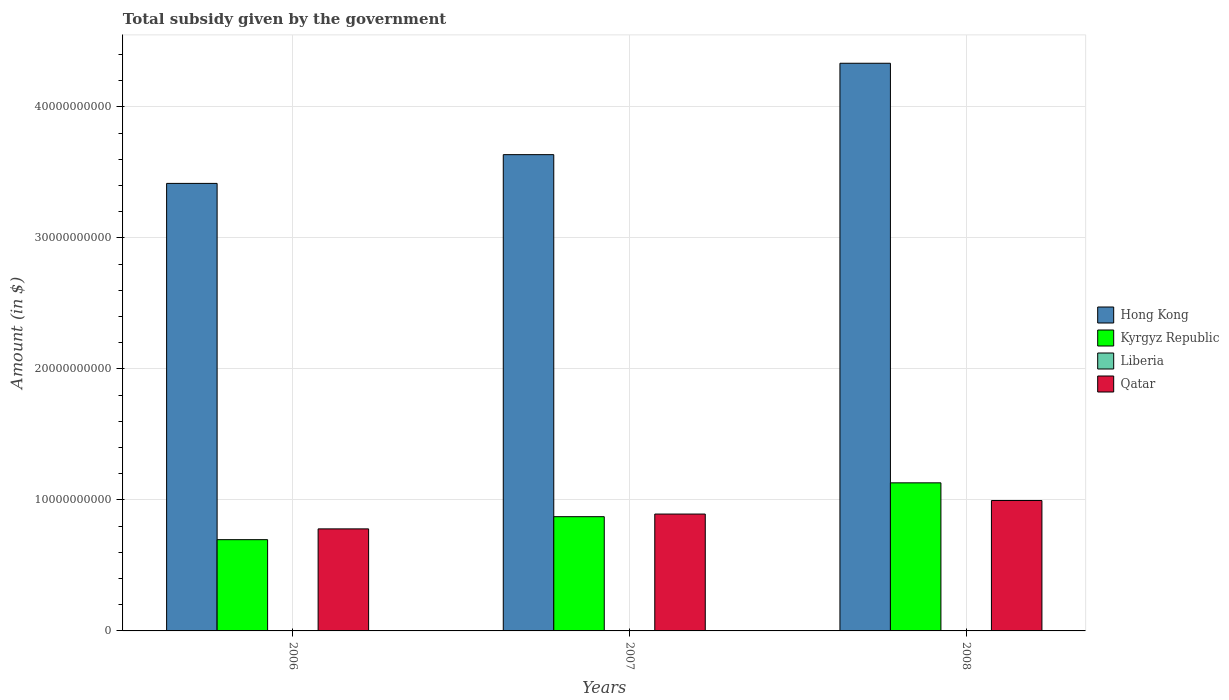How many different coloured bars are there?
Provide a short and direct response. 4. How many groups of bars are there?
Ensure brevity in your answer.  3. Are the number of bars per tick equal to the number of legend labels?
Your answer should be very brief. Yes. Are the number of bars on each tick of the X-axis equal?
Your answer should be compact. Yes. What is the label of the 2nd group of bars from the left?
Provide a succinct answer. 2007. In how many cases, is the number of bars for a given year not equal to the number of legend labels?
Your answer should be compact. 0. What is the total revenue collected by the government in Hong Kong in 2008?
Your answer should be compact. 4.33e+1. Across all years, what is the maximum total revenue collected by the government in Hong Kong?
Make the answer very short. 4.33e+1. Across all years, what is the minimum total revenue collected by the government in Hong Kong?
Your response must be concise. 3.42e+1. In which year was the total revenue collected by the government in Liberia minimum?
Your response must be concise. 2006. What is the total total revenue collected by the government in Hong Kong in the graph?
Make the answer very short. 1.14e+11. What is the difference between the total revenue collected by the government in Kyrgyz Republic in 2006 and that in 2007?
Your answer should be compact. -1.75e+09. What is the difference between the total revenue collected by the government in Kyrgyz Republic in 2007 and the total revenue collected by the government in Liberia in 2006?
Ensure brevity in your answer.  8.72e+09. What is the average total revenue collected by the government in Kyrgyz Republic per year?
Give a very brief answer. 9.00e+09. In the year 2007, what is the difference between the total revenue collected by the government in Qatar and total revenue collected by the government in Hong Kong?
Offer a terse response. -2.74e+1. What is the ratio of the total revenue collected by the government in Hong Kong in 2007 to that in 2008?
Give a very brief answer. 0.84. What is the difference between the highest and the second highest total revenue collected by the government in Hong Kong?
Keep it short and to the point. 6.98e+09. What is the difference between the highest and the lowest total revenue collected by the government in Kyrgyz Republic?
Offer a very short reply. 4.34e+09. Is the sum of the total revenue collected by the government in Kyrgyz Republic in 2006 and 2007 greater than the maximum total revenue collected by the government in Qatar across all years?
Offer a very short reply. Yes. Is it the case that in every year, the sum of the total revenue collected by the government in Kyrgyz Republic and total revenue collected by the government in Hong Kong is greater than the sum of total revenue collected by the government in Liberia and total revenue collected by the government in Qatar?
Provide a short and direct response. No. What does the 3rd bar from the left in 2007 represents?
Offer a very short reply. Liberia. What does the 4th bar from the right in 2008 represents?
Your answer should be very brief. Hong Kong. Is it the case that in every year, the sum of the total revenue collected by the government in Liberia and total revenue collected by the government in Qatar is greater than the total revenue collected by the government in Hong Kong?
Keep it short and to the point. No. Are all the bars in the graph horizontal?
Provide a short and direct response. No. Are the values on the major ticks of Y-axis written in scientific E-notation?
Give a very brief answer. No. Does the graph contain any zero values?
Your answer should be compact. No. Does the graph contain grids?
Give a very brief answer. Yes. How are the legend labels stacked?
Offer a terse response. Vertical. What is the title of the graph?
Provide a succinct answer. Total subsidy given by the government. Does "Chile" appear as one of the legend labels in the graph?
Your answer should be compact. No. What is the label or title of the Y-axis?
Provide a succinct answer. Amount (in $). What is the Amount (in $) of Hong Kong in 2006?
Offer a very short reply. 3.42e+1. What is the Amount (in $) of Kyrgyz Republic in 2006?
Ensure brevity in your answer.  6.97e+09. What is the Amount (in $) in Liberia in 2006?
Make the answer very short. 1.65e+05. What is the Amount (in $) in Qatar in 2006?
Keep it short and to the point. 7.79e+09. What is the Amount (in $) of Hong Kong in 2007?
Your answer should be compact. 3.64e+1. What is the Amount (in $) in Kyrgyz Republic in 2007?
Provide a succinct answer. 8.72e+09. What is the Amount (in $) of Liberia in 2007?
Keep it short and to the point. 2.89e+05. What is the Amount (in $) in Qatar in 2007?
Provide a short and direct response. 8.92e+09. What is the Amount (in $) in Hong Kong in 2008?
Your response must be concise. 4.33e+1. What is the Amount (in $) of Kyrgyz Republic in 2008?
Your answer should be very brief. 1.13e+1. What is the Amount (in $) of Liberia in 2008?
Your answer should be compact. 6.89e+05. What is the Amount (in $) of Qatar in 2008?
Offer a very short reply. 9.95e+09. Across all years, what is the maximum Amount (in $) of Hong Kong?
Offer a terse response. 4.33e+1. Across all years, what is the maximum Amount (in $) in Kyrgyz Republic?
Make the answer very short. 1.13e+1. Across all years, what is the maximum Amount (in $) of Liberia?
Provide a short and direct response. 6.89e+05. Across all years, what is the maximum Amount (in $) of Qatar?
Ensure brevity in your answer.  9.95e+09. Across all years, what is the minimum Amount (in $) of Hong Kong?
Offer a very short reply. 3.42e+1. Across all years, what is the minimum Amount (in $) of Kyrgyz Republic?
Offer a very short reply. 6.97e+09. Across all years, what is the minimum Amount (in $) of Liberia?
Ensure brevity in your answer.  1.65e+05. Across all years, what is the minimum Amount (in $) of Qatar?
Your response must be concise. 7.79e+09. What is the total Amount (in $) of Hong Kong in the graph?
Keep it short and to the point. 1.14e+11. What is the total Amount (in $) of Kyrgyz Republic in the graph?
Provide a short and direct response. 2.70e+1. What is the total Amount (in $) of Liberia in the graph?
Give a very brief answer. 1.14e+06. What is the total Amount (in $) in Qatar in the graph?
Your response must be concise. 2.67e+1. What is the difference between the Amount (in $) in Hong Kong in 2006 and that in 2007?
Offer a terse response. -2.20e+09. What is the difference between the Amount (in $) in Kyrgyz Republic in 2006 and that in 2007?
Provide a succinct answer. -1.75e+09. What is the difference between the Amount (in $) of Liberia in 2006 and that in 2007?
Provide a short and direct response. -1.24e+05. What is the difference between the Amount (in $) in Qatar in 2006 and that in 2007?
Your answer should be very brief. -1.13e+09. What is the difference between the Amount (in $) in Hong Kong in 2006 and that in 2008?
Ensure brevity in your answer.  -9.17e+09. What is the difference between the Amount (in $) of Kyrgyz Republic in 2006 and that in 2008?
Ensure brevity in your answer.  -4.34e+09. What is the difference between the Amount (in $) in Liberia in 2006 and that in 2008?
Your response must be concise. -5.24e+05. What is the difference between the Amount (in $) of Qatar in 2006 and that in 2008?
Your response must be concise. -2.16e+09. What is the difference between the Amount (in $) in Hong Kong in 2007 and that in 2008?
Provide a short and direct response. -6.98e+09. What is the difference between the Amount (in $) in Kyrgyz Republic in 2007 and that in 2008?
Give a very brief answer. -2.58e+09. What is the difference between the Amount (in $) in Liberia in 2007 and that in 2008?
Ensure brevity in your answer.  -4.00e+05. What is the difference between the Amount (in $) of Qatar in 2007 and that in 2008?
Provide a succinct answer. -1.03e+09. What is the difference between the Amount (in $) of Hong Kong in 2006 and the Amount (in $) of Kyrgyz Republic in 2007?
Your answer should be very brief. 2.54e+1. What is the difference between the Amount (in $) in Hong Kong in 2006 and the Amount (in $) in Liberia in 2007?
Offer a very short reply. 3.42e+1. What is the difference between the Amount (in $) of Hong Kong in 2006 and the Amount (in $) of Qatar in 2007?
Your answer should be very brief. 2.52e+1. What is the difference between the Amount (in $) in Kyrgyz Republic in 2006 and the Amount (in $) in Liberia in 2007?
Your response must be concise. 6.97e+09. What is the difference between the Amount (in $) in Kyrgyz Republic in 2006 and the Amount (in $) in Qatar in 2007?
Make the answer very short. -1.95e+09. What is the difference between the Amount (in $) in Liberia in 2006 and the Amount (in $) in Qatar in 2007?
Keep it short and to the point. -8.92e+09. What is the difference between the Amount (in $) of Hong Kong in 2006 and the Amount (in $) of Kyrgyz Republic in 2008?
Give a very brief answer. 2.29e+1. What is the difference between the Amount (in $) of Hong Kong in 2006 and the Amount (in $) of Liberia in 2008?
Keep it short and to the point. 3.42e+1. What is the difference between the Amount (in $) in Hong Kong in 2006 and the Amount (in $) in Qatar in 2008?
Ensure brevity in your answer.  2.42e+1. What is the difference between the Amount (in $) in Kyrgyz Republic in 2006 and the Amount (in $) in Liberia in 2008?
Your answer should be compact. 6.97e+09. What is the difference between the Amount (in $) of Kyrgyz Republic in 2006 and the Amount (in $) of Qatar in 2008?
Give a very brief answer. -2.99e+09. What is the difference between the Amount (in $) of Liberia in 2006 and the Amount (in $) of Qatar in 2008?
Your answer should be very brief. -9.95e+09. What is the difference between the Amount (in $) of Hong Kong in 2007 and the Amount (in $) of Kyrgyz Republic in 2008?
Your answer should be very brief. 2.51e+1. What is the difference between the Amount (in $) of Hong Kong in 2007 and the Amount (in $) of Liberia in 2008?
Your answer should be very brief. 3.64e+1. What is the difference between the Amount (in $) in Hong Kong in 2007 and the Amount (in $) in Qatar in 2008?
Give a very brief answer. 2.64e+1. What is the difference between the Amount (in $) in Kyrgyz Republic in 2007 and the Amount (in $) in Liberia in 2008?
Offer a terse response. 8.72e+09. What is the difference between the Amount (in $) in Kyrgyz Republic in 2007 and the Amount (in $) in Qatar in 2008?
Your answer should be very brief. -1.23e+09. What is the difference between the Amount (in $) in Liberia in 2007 and the Amount (in $) in Qatar in 2008?
Offer a very short reply. -9.95e+09. What is the average Amount (in $) of Hong Kong per year?
Provide a succinct answer. 3.79e+1. What is the average Amount (in $) of Kyrgyz Republic per year?
Your response must be concise. 9.00e+09. What is the average Amount (in $) of Liberia per year?
Ensure brevity in your answer.  3.81e+05. What is the average Amount (in $) in Qatar per year?
Provide a short and direct response. 8.89e+09. In the year 2006, what is the difference between the Amount (in $) in Hong Kong and Amount (in $) in Kyrgyz Republic?
Offer a very short reply. 2.72e+1. In the year 2006, what is the difference between the Amount (in $) in Hong Kong and Amount (in $) in Liberia?
Keep it short and to the point. 3.42e+1. In the year 2006, what is the difference between the Amount (in $) in Hong Kong and Amount (in $) in Qatar?
Provide a succinct answer. 2.64e+1. In the year 2006, what is the difference between the Amount (in $) in Kyrgyz Republic and Amount (in $) in Liberia?
Keep it short and to the point. 6.97e+09. In the year 2006, what is the difference between the Amount (in $) in Kyrgyz Republic and Amount (in $) in Qatar?
Offer a terse response. -8.22e+08. In the year 2006, what is the difference between the Amount (in $) in Liberia and Amount (in $) in Qatar?
Your answer should be very brief. -7.79e+09. In the year 2007, what is the difference between the Amount (in $) of Hong Kong and Amount (in $) of Kyrgyz Republic?
Your response must be concise. 2.76e+1. In the year 2007, what is the difference between the Amount (in $) of Hong Kong and Amount (in $) of Liberia?
Ensure brevity in your answer.  3.64e+1. In the year 2007, what is the difference between the Amount (in $) of Hong Kong and Amount (in $) of Qatar?
Provide a short and direct response. 2.74e+1. In the year 2007, what is the difference between the Amount (in $) in Kyrgyz Republic and Amount (in $) in Liberia?
Offer a very short reply. 8.72e+09. In the year 2007, what is the difference between the Amount (in $) in Kyrgyz Republic and Amount (in $) in Qatar?
Ensure brevity in your answer.  -2.00e+08. In the year 2007, what is the difference between the Amount (in $) of Liberia and Amount (in $) of Qatar?
Ensure brevity in your answer.  -8.92e+09. In the year 2008, what is the difference between the Amount (in $) of Hong Kong and Amount (in $) of Kyrgyz Republic?
Ensure brevity in your answer.  3.20e+1. In the year 2008, what is the difference between the Amount (in $) of Hong Kong and Amount (in $) of Liberia?
Offer a terse response. 4.33e+1. In the year 2008, what is the difference between the Amount (in $) of Hong Kong and Amount (in $) of Qatar?
Your answer should be compact. 3.34e+1. In the year 2008, what is the difference between the Amount (in $) in Kyrgyz Republic and Amount (in $) in Liberia?
Offer a very short reply. 1.13e+1. In the year 2008, what is the difference between the Amount (in $) in Kyrgyz Republic and Amount (in $) in Qatar?
Offer a terse response. 1.35e+09. In the year 2008, what is the difference between the Amount (in $) in Liberia and Amount (in $) in Qatar?
Provide a succinct answer. -9.95e+09. What is the ratio of the Amount (in $) in Hong Kong in 2006 to that in 2007?
Provide a short and direct response. 0.94. What is the ratio of the Amount (in $) in Kyrgyz Republic in 2006 to that in 2007?
Provide a short and direct response. 0.8. What is the ratio of the Amount (in $) of Liberia in 2006 to that in 2007?
Keep it short and to the point. 0.57. What is the ratio of the Amount (in $) in Qatar in 2006 to that in 2007?
Provide a short and direct response. 0.87. What is the ratio of the Amount (in $) in Hong Kong in 2006 to that in 2008?
Your answer should be compact. 0.79. What is the ratio of the Amount (in $) in Kyrgyz Republic in 2006 to that in 2008?
Give a very brief answer. 0.62. What is the ratio of the Amount (in $) in Liberia in 2006 to that in 2008?
Your response must be concise. 0.24. What is the ratio of the Amount (in $) in Qatar in 2006 to that in 2008?
Offer a very short reply. 0.78. What is the ratio of the Amount (in $) of Hong Kong in 2007 to that in 2008?
Give a very brief answer. 0.84. What is the ratio of the Amount (in $) of Kyrgyz Republic in 2007 to that in 2008?
Give a very brief answer. 0.77. What is the ratio of the Amount (in $) of Liberia in 2007 to that in 2008?
Provide a succinct answer. 0.42. What is the ratio of the Amount (in $) of Qatar in 2007 to that in 2008?
Keep it short and to the point. 0.9. What is the difference between the highest and the second highest Amount (in $) of Hong Kong?
Ensure brevity in your answer.  6.98e+09. What is the difference between the highest and the second highest Amount (in $) in Kyrgyz Republic?
Keep it short and to the point. 2.58e+09. What is the difference between the highest and the second highest Amount (in $) of Liberia?
Your response must be concise. 4.00e+05. What is the difference between the highest and the second highest Amount (in $) of Qatar?
Provide a short and direct response. 1.03e+09. What is the difference between the highest and the lowest Amount (in $) in Hong Kong?
Provide a succinct answer. 9.17e+09. What is the difference between the highest and the lowest Amount (in $) of Kyrgyz Republic?
Provide a succinct answer. 4.34e+09. What is the difference between the highest and the lowest Amount (in $) of Liberia?
Give a very brief answer. 5.24e+05. What is the difference between the highest and the lowest Amount (in $) in Qatar?
Your response must be concise. 2.16e+09. 